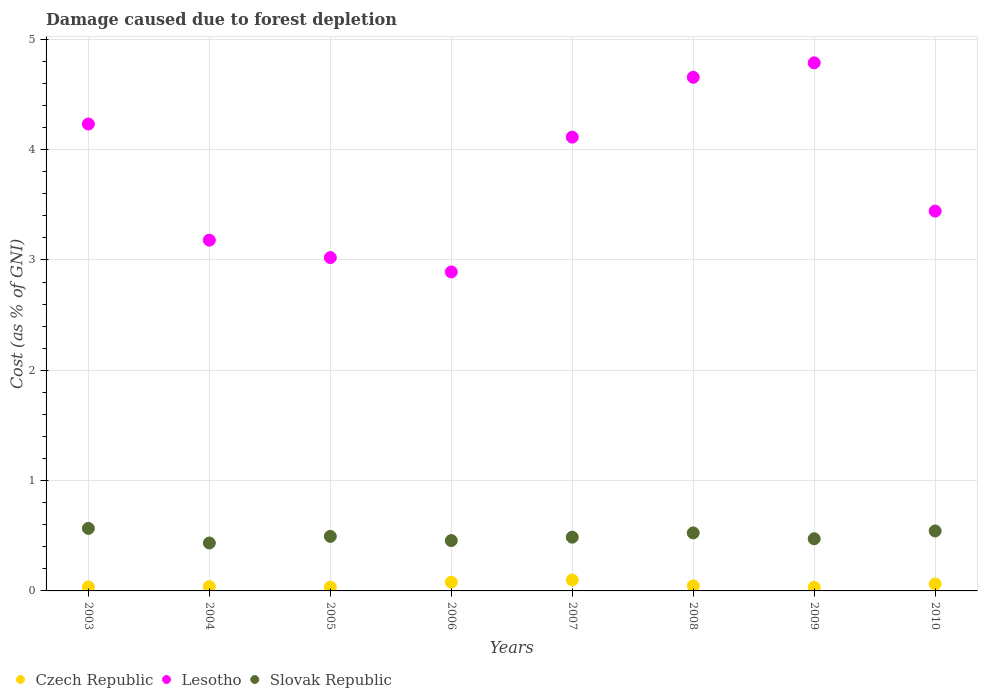What is the cost of damage caused due to forest depletion in Czech Republic in 2004?
Your answer should be compact. 0.04. Across all years, what is the maximum cost of damage caused due to forest depletion in Lesotho?
Offer a terse response. 4.79. Across all years, what is the minimum cost of damage caused due to forest depletion in Lesotho?
Your answer should be very brief. 2.89. What is the total cost of damage caused due to forest depletion in Czech Republic in the graph?
Ensure brevity in your answer.  0.43. What is the difference between the cost of damage caused due to forest depletion in Slovak Republic in 2003 and that in 2007?
Provide a succinct answer. 0.08. What is the difference between the cost of damage caused due to forest depletion in Lesotho in 2003 and the cost of damage caused due to forest depletion in Czech Republic in 2009?
Offer a very short reply. 4.2. What is the average cost of damage caused due to forest depletion in Slovak Republic per year?
Offer a terse response. 0.5. In the year 2009, what is the difference between the cost of damage caused due to forest depletion in Czech Republic and cost of damage caused due to forest depletion in Slovak Republic?
Keep it short and to the point. -0.44. In how many years, is the cost of damage caused due to forest depletion in Czech Republic greater than 0.8 %?
Offer a terse response. 0. What is the ratio of the cost of damage caused due to forest depletion in Czech Republic in 2007 to that in 2009?
Your response must be concise. 3.05. Is the cost of damage caused due to forest depletion in Lesotho in 2006 less than that in 2009?
Offer a very short reply. Yes. What is the difference between the highest and the second highest cost of damage caused due to forest depletion in Slovak Republic?
Your answer should be compact. 0.02. What is the difference between the highest and the lowest cost of damage caused due to forest depletion in Czech Republic?
Provide a succinct answer. 0.07. Is the sum of the cost of damage caused due to forest depletion in Slovak Republic in 2007 and 2010 greater than the maximum cost of damage caused due to forest depletion in Czech Republic across all years?
Your answer should be compact. Yes. Is it the case that in every year, the sum of the cost of damage caused due to forest depletion in Lesotho and cost of damage caused due to forest depletion in Czech Republic  is greater than the cost of damage caused due to forest depletion in Slovak Republic?
Your answer should be very brief. Yes. Does the cost of damage caused due to forest depletion in Czech Republic monotonically increase over the years?
Your answer should be compact. No. Is the cost of damage caused due to forest depletion in Czech Republic strictly less than the cost of damage caused due to forest depletion in Lesotho over the years?
Offer a terse response. Yes. How many years are there in the graph?
Your answer should be very brief. 8. Are the values on the major ticks of Y-axis written in scientific E-notation?
Give a very brief answer. No. Does the graph contain any zero values?
Ensure brevity in your answer.  No. Does the graph contain grids?
Keep it short and to the point. Yes. How are the legend labels stacked?
Offer a terse response. Horizontal. What is the title of the graph?
Your response must be concise. Damage caused due to forest depletion. Does "Canada" appear as one of the legend labels in the graph?
Provide a succinct answer. No. What is the label or title of the Y-axis?
Make the answer very short. Cost (as % of GNI). What is the Cost (as % of GNI) of Czech Republic in 2003?
Provide a short and direct response. 0.04. What is the Cost (as % of GNI) of Lesotho in 2003?
Offer a terse response. 4.23. What is the Cost (as % of GNI) in Slovak Republic in 2003?
Ensure brevity in your answer.  0.57. What is the Cost (as % of GNI) of Czech Republic in 2004?
Give a very brief answer. 0.04. What is the Cost (as % of GNI) of Lesotho in 2004?
Give a very brief answer. 3.18. What is the Cost (as % of GNI) in Slovak Republic in 2004?
Provide a short and direct response. 0.43. What is the Cost (as % of GNI) of Czech Republic in 2005?
Your response must be concise. 0.03. What is the Cost (as % of GNI) in Lesotho in 2005?
Make the answer very short. 3.02. What is the Cost (as % of GNI) in Slovak Republic in 2005?
Make the answer very short. 0.49. What is the Cost (as % of GNI) in Czech Republic in 2006?
Ensure brevity in your answer.  0.08. What is the Cost (as % of GNI) in Lesotho in 2006?
Provide a succinct answer. 2.89. What is the Cost (as % of GNI) in Slovak Republic in 2006?
Offer a very short reply. 0.46. What is the Cost (as % of GNI) in Czech Republic in 2007?
Make the answer very short. 0.1. What is the Cost (as % of GNI) in Lesotho in 2007?
Keep it short and to the point. 4.11. What is the Cost (as % of GNI) in Slovak Republic in 2007?
Provide a short and direct response. 0.49. What is the Cost (as % of GNI) in Czech Republic in 2008?
Provide a succinct answer. 0.05. What is the Cost (as % of GNI) in Lesotho in 2008?
Give a very brief answer. 4.66. What is the Cost (as % of GNI) of Slovak Republic in 2008?
Provide a succinct answer. 0.53. What is the Cost (as % of GNI) in Czech Republic in 2009?
Your answer should be compact. 0.03. What is the Cost (as % of GNI) in Lesotho in 2009?
Provide a succinct answer. 4.79. What is the Cost (as % of GNI) in Slovak Republic in 2009?
Offer a very short reply. 0.47. What is the Cost (as % of GNI) in Czech Republic in 2010?
Provide a succinct answer. 0.06. What is the Cost (as % of GNI) of Lesotho in 2010?
Provide a succinct answer. 3.44. What is the Cost (as % of GNI) in Slovak Republic in 2010?
Offer a very short reply. 0.54. Across all years, what is the maximum Cost (as % of GNI) of Czech Republic?
Provide a short and direct response. 0.1. Across all years, what is the maximum Cost (as % of GNI) in Lesotho?
Give a very brief answer. 4.79. Across all years, what is the maximum Cost (as % of GNI) in Slovak Republic?
Provide a short and direct response. 0.57. Across all years, what is the minimum Cost (as % of GNI) in Czech Republic?
Keep it short and to the point. 0.03. Across all years, what is the minimum Cost (as % of GNI) in Lesotho?
Your answer should be very brief. 2.89. Across all years, what is the minimum Cost (as % of GNI) in Slovak Republic?
Your response must be concise. 0.43. What is the total Cost (as % of GNI) of Czech Republic in the graph?
Keep it short and to the point. 0.43. What is the total Cost (as % of GNI) of Lesotho in the graph?
Your answer should be very brief. 30.33. What is the total Cost (as % of GNI) in Slovak Republic in the graph?
Ensure brevity in your answer.  3.98. What is the difference between the Cost (as % of GNI) in Czech Republic in 2003 and that in 2004?
Your response must be concise. -0. What is the difference between the Cost (as % of GNI) of Lesotho in 2003 and that in 2004?
Your answer should be very brief. 1.05. What is the difference between the Cost (as % of GNI) in Slovak Republic in 2003 and that in 2004?
Keep it short and to the point. 0.13. What is the difference between the Cost (as % of GNI) in Czech Republic in 2003 and that in 2005?
Ensure brevity in your answer.  0. What is the difference between the Cost (as % of GNI) of Lesotho in 2003 and that in 2005?
Offer a very short reply. 1.21. What is the difference between the Cost (as % of GNI) in Slovak Republic in 2003 and that in 2005?
Offer a very short reply. 0.07. What is the difference between the Cost (as % of GNI) in Czech Republic in 2003 and that in 2006?
Give a very brief answer. -0.04. What is the difference between the Cost (as % of GNI) of Lesotho in 2003 and that in 2006?
Give a very brief answer. 1.34. What is the difference between the Cost (as % of GNI) in Slovak Republic in 2003 and that in 2006?
Make the answer very short. 0.11. What is the difference between the Cost (as % of GNI) of Czech Republic in 2003 and that in 2007?
Provide a short and direct response. -0.06. What is the difference between the Cost (as % of GNI) of Lesotho in 2003 and that in 2007?
Your answer should be compact. 0.12. What is the difference between the Cost (as % of GNI) of Slovak Republic in 2003 and that in 2007?
Your answer should be compact. 0.08. What is the difference between the Cost (as % of GNI) in Czech Republic in 2003 and that in 2008?
Ensure brevity in your answer.  -0.01. What is the difference between the Cost (as % of GNI) of Lesotho in 2003 and that in 2008?
Provide a short and direct response. -0.42. What is the difference between the Cost (as % of GNI) of Slovak Republic in 2003 and that in 2008?
Give a very brief answer. 0.04. What is the difference between the Cost (as % of GNI) in Czech Republic in 2003 and that in 2009?
Your answer should be very brief. 0. What is the difference between the Cost (as % of GNI) of Lesotho in 2003 and that in 2009?
Provide a succinct answer. -0.56. What is the difference between the Cost (as % of GNI) of Slovak Republic in 2003 and that in 2009?
Provide a short and direct response. 0.09. What is the difference between the Cost (as % of GNI) in Czech Republic in 2003 and that in 2010?
Offer a very short reply. -0.03. What is the difference between the Cost (as % of GNI) in Lesotho in 2003 and that in 2010?
Keep it short and to the point. 0.79. What is the difference between the Cost (as % of GNI) in Slovak Republic in 2003 and that in 2010?
Your response must be concise. 0.02. What is the difference between the Cost (as % of GNI) in Czech Republic in 2004 and that in 2005?
Provide a short and direct response. 0. What is the difference between the Cost (as % of GNI) of Lesotho in 2004 and that in 2005?
Give a very brief answer. 0.16. What is the difference between the Cost (as % of GNI) in Slovak Republic in 2004 and that in 2005?
Offer a terse response. -0.06. What is the difference between the Cost (as % of GNI) in Czech Republic in 2004 and that in 2006?
Ensure brevity in your answer.  -0.04. What is the difference between the Cost (as % of GNI) in Lesotho in 2004 and that in 2006?
Your answer should be very brief. 0.29. What is the difference between the Cost (as % of GNI) in Slovak Republic in 2004 and that in 2006?
Provide a succinct answer. -0.02. What is the difference between the Cost (as % of GNI) in Czech Republic in 2004 and that in 2007?
Provide a short and direct response. -0.06. What is the difference between the Cost (as % of GNI) of Lesotho in 2004 and that in 2007?
Give a very brief answer. -0.93. What is the difference between the Cost (as % of GNI) of Slovak Republic in 2004 and that in 2007?
Offer a terse response. -0.05. What is the difference between the Cost (as % of GNI) in Czech Republic in 2004 and that in 2008?
Keep it short and to the point. -0.01. What is the difference between the Cost (as % of GNI) of Lesotho in 2004 and that in 2008?
Ensure brevity in your answer.  -1.48. What is the difference between the Cost (as % of GNI) of Slovak Republic in 2004 and that in 2008?
Offer a terse response. -0.09. What is the difference between the Cost (as % of GNI) of Czech Republic in 2004 and that in 2009?
Offer a terse response. 0.01. What is the difference between the Cost (as % of GNI) in Lesotho in 2004 and that in 2009?
Offer a terse response. -1.61. What is the difference between the Cost (as % of GNI) of Slovak Republic in 2004 and that in 2009?
Ensure brevity in your answer.  -0.04. What is the difference between the Cost (as % of GNI) of Czech Republic in 2004 and that in 2010?
Ensure brevity in your answer.  -0.02. What is the difference between the Cost (as % of GNI) in Lesotho in 2004 and that in 2010?
Provide a succinct answer. -0.26. What is the difference between the Cost (as % of GNI) of Slovak Republic in 2004 and that in 2010?
Make the answer very short. -0.11. What is the difference between the Cost (as % of GNI) of Czech Republic in 2005 and that in 2006?
Give a very brief answer. -0.04. What is the difference between the Cost (as % of GNI) of Lesotho in 2005 and that in 2006?
Give a very brief answer. 0.13. What is the difference between the Cost (as % of GNI) in Slovak Republic in 2005 and that in 2006?
Provide a succinct answer. 0.04. What is the difference between the Cost (as % of GNI) in Czech Republic in 2005 and that in 2007?
Make the answer very short. -0.06. What is the difference between the Cost (as % of GNI) of Lesotho in 2005 and that in 2007?
Ensure brevity in your answer.  -1.09. What is the difference between the Cost (as % of GNI) of Slovak Republic in 2005 and that in 2007?
Keep it short and to the point. 0.01. What is the difference between the Cost (as % of GNI) in Czech Republic in 2005 and that in 2008?
Offer a very short reply. -0.01. What is the difference between the Cost (as % of GNI) of Lesotho in 2005 and that in 2008?
Give a very brief answer. -1.63. What is the difference between the Cost (as % of GNI) of Slovak Republic in 2005 and that in 2008?
Offer a terse response. -0.03. What is the difference between the Cost (as % of GNI) of Czech Republic in 2005 and that in 2009?
Keep it short and to the point. 0. What is the difference between the Cost (as % of GNI) in Lesotho in 2005 and that in 2009?
Ensure brevity in your answer.  -1.77. What is the difference between the Cost (as % of GNI) of Slovak Republic in 2005 and that in 2009?
Your answer should be very brief. 0.02. What is the difference between the Cost (as % of GNI) in Czech Republic in 2005 and that in 2010?
Offer a very short reply. -0.03. What is the difference between the Cost (as % of GNI) of Lesotho in 2005 and that in 2010?
Ensure brevity in your answer.  -0.42. What is the difference between the Cost (as % of GNI) of Slovak Republic in 2005 and that in 2010?
Ensure brevity in your answer.  -0.05. What is the difference between the Cost (as % of GNI) of Czech Republic in 2006 and that in 2007?
Offer a very short reply. -0.02. What is the difference between the Cost (as % of GNI) of Lesotho in 2006 and that in 2007?
Your response must be concise. -1.22. What is the difference between the Cost (as % of GNI) of Slovak Republic in 2006 and that in 2007?
Your response must be concise. -0.03. What is the difference between the Cost (as % of GNI) of Czech Republic in 2006 and that in 2008?
Your response must be concise. 0.03. What is the difference between the Cost (as % of GNI) of Lesotho in 2006 and that in 2008?
Provide a short and direct response. -1.76. What is the difference between the Cost (as % of GNI) of Slovak Republic in 2006 and that in 2008?
Offer a very short reply. -0.07. What is the difference between the Cost (as % of GNI) of Czech Republic in 2006 and that in 2009?
Your response must be concise. 0.05. What is the difference between the Cost (as % of GNI) in Lesotho in 2006 and that in 2009?
Provide a succinct answer. -1.9. What is the difference between the Cost (as % of GNI) of Slovak Republic in 2006 and that in 2009?
Provide a short and direct response. -0.02. What is the difference between the Cost (as % of GNI) of Czech Republic in 2006 and that in 2010?
Offer a very short reply. 0.02. What is the difference between the Cost (as % of GNI) of Lesotho in 2006 and that in 2010?
Provide a short and direct response. -0.55. What is the difference between the Cost (as % of GNI) of Slovak Republic in 2006 and that in 2010?
Provide a short and direct response. -0.09. What is the difference between the Cost (as % of GNI) in Czech Republic in 2007 and that in 2008?
Make the answer very short. 0.05. What is the difference between the Cost (as % of GNI) in Lesotho in 2007 and that in 2008?
Your answer should be very brief. -0.54. What is the difference between the Cost (as % of GNI) of Slovak Republic in 2007 and that in 2008?
Provide a short and direct response. -0.04. What is the difference between the Cost (as % of GNI) of Czech Republic in 2007 and that in 2009?
Offer a very short reply. 0.07. What is the difference between the Cost (as % of GNI) of Lesotho in 2007 and that in 2009?
Offer a very short reply. -0.67. What is the difference between the Cost (as % of GNI) in Slovak Republic in 2007 and that in 2009?
Keep it short and to the point. 0.01. What is the difference between the Cost (as % of GNI) in Czech Republic in 2007 and that in 2010?
Ensure brevity in your answer.  0.04. What is the difference between the Cost (as % of GNI) in Lesotho in 2007 and that in 2010?
Your answer should be very brief. 0.67. What is the difference between the Cost (as % of GNI) in Slovak Republic in 2007 and that in 2010?
Your answer should be compact. -0.06. What is the difference between the Cost (as % of GNI) in Czech Republic in 2008 and that in 2009?
Provide a succinct answer. 0.01. What is the difference between the Cost (as % of GNI) of Lesotho in 2008 and that in 2009?
Offer a very short reply. -0.13. What is the difference between the Cost (as % of GNI) in Slovak Republic in 2008 and that in 2009?
Your response must be concise. 0.05. What is the difference between the Cost (as % of GNI) of Czech Republic in 2008 and that in 2010?
Provide a short and direct response. -0.02. What is the difference between the Cost (as % of GNI) in Lesotho in 2008 and that in 2010?
Offer a terse response. 1.21. What is the difference between the Cost (as % of GNI) of Slovak Republic in 2008 and that in 2010?
Your answer should be very brief. -0.02. What is the difference between the Cost (as % of GNI) of Czech Republic in 2009 and that in 2010?
Keep it short and to the point. -0.03. What is the difference between the Cost (as % of GNI) of Lesotho in 2009 and that in 2010?
Ensure brevity in your answer.  1.34. What is the difference between the Cost (as % of GNI) in Slovak Republic in 2009 and that in 2010?
Keep it short and to the point. -0.07. What is the difference between the Cost (as % of GNI) of Czech Republic in 2003 and the Cost (as % of GNI) of Lesotho in 2004?
Keep it short and to the point. -3.14. What is the difference between the Cost (as % of GNI) of Czech Republic in 2003 and the Cost (as % of GNI) of Slovak Republic in 2004?
Offer a very short reply. -0.4. What is the difference between the Cost (as % of GNI) in Lesotho in 2003 and the Cost (as % of GNI) in Slovak Republic in 2004?
Make the answer very short. 3.8. What is the difference between the Cost (as % of GNI) in Czech Republic in 2003 and the Cost (as % of GNI) in Lesotho in 2005?
Keep it short and to the point. -2.99. What is the difference between the Cost (as % of GNI) in Czech Republic in 2003 and the Cost (as % of GNI) in Slovak Republic in 2005?
Keep it short and to the point. -0.46. What is the difference between the Cost (as % of GNI) in Lesotho in 2003 and the Cost (as % of GNI) in Slovak Republic in 2005?
Your answer should be compact. 3.74. What is the difference between the Cost (as % of GNI) in Czech Republic in 2003 and the Cost (as % of GNI) in Lesotho in 2006?
Give a very brief answer. -2.86. What is the difference between the Cost (as % of GNI) of Czech Republic in 2003 and the Cost (as % of GNI) of Slovak Republic in 2006?
Provide a short and direct response. -0.42. What is the difference between the Cost (as % of GNI) of Lesotho in 2003 and the Cost (as % of GNI) of Slovak Republic in 2006?
Ensure brevity in your answer.  3.78. What is the difference between the Cost (as % of GNI) of Czech Republic in 2003 and the Cost (as % of GNI) of Lesotho in 2007?
Your answer should be compact. -4.08. What is the difference between the Cost (as % of GNI) in Czech Republic in 2003 and the Cost (as % of GNI) in Slovak Republic in 2007?
Keep it short and to the point. -0.45. What is the difference between the Cost (as % of GNI) of Lesotho in 2003 and the Cost (as % of GNI) of Slovak Republic in 2007?
Provide a short and direct response. 3.75. What is the difference between the Cost (as % of GNI) of Czech Republic in 2003 and the Cost (as % of GNI) of Lesotho in 2008?
Keep it short and to the point. -4.62. What is the difference between the Cost (as % of GNI) of Czech Republic in 2003 and the Cost (as % of GNI) of Slovak Republic in 2008?
Offer a very short reply. -0.49. What is the difference between the Cost (as % of GNI) of Lesotho in 2003 and the Cost (as % of GNI) of Slovak Republic in 2008?
Your answer should be very brief. 3.71. What is the difference between the Cost (as % of GNI) of Czech Republic in 2003 and the Cost (as % of GNI) of Lesotho in 2009?
Your answer should be compact. -4.75. What is the difference between the Cost (as % of GNI) of Czech Republic in 2003 and the Cost (as % of GNI) of Slovak Republic in 2009?
Ensure brevity in your answer.  -0.44. What is the difference between the Cost (as % of GNI) in Lesotho in 2003 and the Cost (as % of GNI) in Slovak Republic in 2009?
Ensure brevity in your answer.  3.76. What is the difference between the Cost (as % of GNI) of Czech Republic in 2003 and the Cost (as % of GNI) of Lesotho in 2010?
Your response must be concise. -3.41. What is the difference between the Cost (as % of GNI) in Czech Republic in 2003 and the Cost (as % of GNI) in Slovak Republic in 2010?
Make the answer very short. -0.51. What is the difference between the Cost (as % of GNI) of Lesotho in 2003 and the Cost (as % of GNI) of Slovak Republic in 2010?
Your response must be concise. 3.69. What is the difference between the Cost (as % of GNI) of Czech Republic in 2004 and the Cost (as % of GNI) of Lesotho in 2005?
Your answer should be compact. -2.98. What is the difference between the Cost (as % of GNI) of Czech Republic in 2004 and the Cost (as % of GNI) of Slovak Republic in 2005?
Provide a short and direct response. -0.46. What is the difference between the Cost (as % of GNI) of Lesotho in 2004 and the Cost (as % of GNI) of Slovak Republic in 2005?
Your answer should be compact. 2.69. What is the difference between the Cost (as % of GNI) in Czech Republic in 2004 and the Cost (as % of GNI) in Lesotho in 2006?
Give a very brief answer. -2.85. What is the difference between the Cost (as % of GNI) of Czech Republic in 2004 and the Cost (as % of GNI) of Slovak Republic in 2006?
Make the answer very short. -0.42. What is the difference between the Cost (as % of GNI) in Lesotho in 2004 and the Cost (as % of GNI) in Slovak Republic in 2006?
Offer a terse response. 2.72. What is the difference between the Cost (as % of GNI) in Czech Republic in 2004 and the Cost (as % of GNI) in Lesotho in 2007?
Your answer should be very brief. -4.07. What is the difference between the Cost (as % of GNI) in Czech Republic in 2004 and the Cost (as % of GNI) in Slovak Republic in 2007?
Your answer should be very brief. -0.45. What is the difference between the Cost (as % of GNI) of Lesotho in 2004 and the Cost (as % of GNI) of Slovak Republic in 2007?
Your answer should be very brief. 2.69. What is the difference between the Cost (as % of GNI) of Czech Republic in 2004 and the Cost (as % of GNI) of Lesotho in 2008?
Offer a very short reply. -4.62. What is the difference between the Cost (as % of GNI) in Czech Republic in 2004 and the Cost (as % of GNI) in Slovak Republic in 2008?
Ensure brevity in your answer.  -0.49. What is the difference between the Cost (as % of GNI) in Lesotho in 2004 and the Cost (as % of GNI) in Slovak Republic in 2008?
Provide a short and direct response. 2.65. What is the difference between the Cost (as % of GNI) in Czech Republic in 2004 and the Cost (as % of GNI) in Lesotho in 2009?
Make the answer very short. -4.75. What is the difference between the Cost (as % of GNI) of Czech Republic in 2004 and the Cost (as % of GNI) of Slovak Republic in 2009?
Offer a terse response. -0.43. What is the difference between the Cost (as % of GNI) in Lesotho in 2004 and the Cost (as % of GNI) in Slovak Republic in 2009?
Give a very brief answer. 2.71. What is the difference between the Cost (as % of GNI) of Czech Republic in 2004 and the Cost (as % of GNI) of Lesotho in 2010?
Provide a succinct answer. -3.4. What is the difference between the Cost (as % of GNI) of Czech Republic in 2004 and the Cost (as % of GNI) of Slovak Republic in 2010?
Your answer should be very brief. -0.5. What is the difference between the Cost (as % of GNI) in Lesotho in 2004 and the Cost (as % of GNI) in Slovak Republic in 2010?
Offer a terse response. 2.64. What is the difference between the Cost (as % of GNI) in Czech Republic in 2005 and the Cost (as % of GNI) in Lesotho in 2006?
Ensure brevity in your answer.  -2.86. What is the difference between the Cost (as % of GNI) in Czech Republic in 2005 and the Cost (as % of GNI) in Slovak Republic in 2006?
Provide a short and direct response. -0.42. What is the difference between the Cost (as % of GNI) in Lesotho in 2005 and the Cost (as % of GNI) in Slovak Republic in 2006?
Provide a short and direct response. 2.57. What is the difference between the Cost (as % of GNI) of Czech Republic in 2005 and the Cost (as % of GNI) of Lesotho in 2007?
Keep it short and to the point. -4.08. What is the difference between the Cost (as % of GNI) of Czech Republic in 2005 and the Cost (as % of GNI) of Slovak Republic in 2007?
Ensure brevity in your answer.  -0.45. What is the difference between the Cost (as % of GNI) in Lesotho in 2005 and the Cost (as % of GNI) in Slovak Republic in 2007?
Keep it short and to the point. 2.53. What is the difference between the Cost (as % of GNI) of Czech Republic in 2005 and the Cost (as % of GNI) of Lesotho in 2008?
Offer a very short reply. -4.62. What is the difference between the Cost (as % of GNI) in Czech Republic in 2005 and the Cost (as % of GNI) in Slovak Republic in 2008?
Your answer should be very brief. -0.49. What is the difference between the Cost (as % of GNI) in Lesotho in 2005 and the Cost (as % of GNI) in Slovak Republic in 2008?
Your answer should be very brief. 2.5. What is the difference between the Cost (as % of GNI) of Czech Republic in 2005 and the Cost (as % of GNI) of Lesotho in 2009?
Give a very brief answer. -4.75. What is the difference between the Cost (as % of GNI) in Czech Republic in 2005 and the Cost (as % of GNI) in Slovak Republic in 2009?
Make the answer very short. -0.44. What is the difference between the Cost (as % of GNI) in Lesotho in 2005 and the Cost (as % of GNI) in Slovak Republic in 2009?
Provide a succinct answer. 2.55. What is the difference between the Cost (as % of GNI) of Czech Republic in 2005 and the Cost (as % of GNI) of Lesotho in 2010?
Your answer should be compact. -3.41. What is the difference between the Cost (as % of GNI) in Czech Republic in 2005 and the Cost (as % of GNI) in Slovak Republic in 2010?
Your answer should be very brief. -0.51. What is the difference between the Cost (as % of GNI) in Lesotho in 2005 and the Cost (as % of GNI) in Slovak Republic in 2010?
Ensure brevity in your answer.  2.48. What is the difference between the Cost (as % of GNI) in Czech Republic in 2006 and the Cost (as % of GNI) in Lesotho in 2007?
Provide a short and direct response. -4.03. What is the difference between the Cost (as % of GNI) of Czech Republic in 2006 and the Cost (as % of GNI) of Slovak Republic in 2007?
Offer a terse response. -0.41. What is the difference between the Cost (as % of GNI) of Lesotho in 2006 and the Cost (as % of GNI) of Slovak Republic in 2007?
Your answer should be compact. 2.4. What is the difference between the Cost (as % of GNI) of Czech Republic in 2006 and the Cost (as % of GNI) of Lesotho in 2008?
Make the answer very short. -4.58. What is the difference between the Cost (as % of GNI) of Czech Republic in 2006 and the Cost (as % of GNI) of Slovak Republic in 2008?
Make the answer very short. -0.45. What is the difference between the Cost (as % of GNI) of Lesotho in 2006 and the Cost (as % of GNI) of Slovak Republic in 2008?
Give a very brief answer. 2.37. What is the difference between the Cost (as % of GNI) in Czech Republic in 2006 and the Cost (as % of GNI) in Lesotho in 2009?
Keep it short and to the point. -4.71. What is the difference between the Cost (as % of GNI) in Czech Republic in 2006 and the Cost (as % of GNI) in Slovak Republic in 2009?
Provide a short and direct response. -0.39. What is the difference between the Cost (as % of GNI) in Lesotho in 2006 and the Cost (as % of GNI) in Slovak Republic in 2009?
Your answer should be very brief. 2.42. What is the difference between the Cost (as % of GNI) in Czech Republic in 2006 and the Cost (as % of GNI) in Lesotho in 2010?
Ensure brevity in your answer.  -3.36. What is the difference between the Cost (as % of GNI) in Czech Republic in 2006 and the Cost (as % of GNI) in Slovak Republic in 2010?
Provide a short and direct response. -0.46. What is the difference between the Cost (as % of GNI) in Lesotho in 2006 and the Cost (as % of GNI) in Slovak Republic in 2010?
Your answer should be compact. 2.35. What is the difference between the Cost (as % of GNI) in Czech Republic in 2007 and the Cost (as % of GNI) in Lesotho in 2008?
Ensure brevity in your answer.  -4.56. What is the difference between the Cost (as % of GNI) in Czech Republic in 2007 and the Cost (as % of GNI) in Slovak Republic in 2008?
Provide a succinct answer. -0.43. What is the difference between the Cost (as % of GNI) of Lesotho in 2007 and the Cost (as % of GNI) of Slovak Republic in 2008?
Offer a terse response. 3.59. What is the difference between the Cost (as % of GNI) in Czech Republic in 2007 and the Cost (as % of GNI) in Lesotho in 2009?
Give a very brief answer. -4.69. What is the difference between the Cost (as % of GNI) in Czech Republic in 2007 and the Cost (as % of GNI) in Slovak Republic in 2009?
Ensure brevity in your answer.  -0.37. What is the difference between the Cost (as % of GNI) in Lesotho in 2007 and the Cost (as % of GNI) in Slovak Republic in 2009?
Make the answer very short. 3.64. What is the difference between the Cost (as % of GNI) of Czech Republic in 2007 and the Cost (as % of GNI) of Lesotho in 2010?
Offer a terse response. -3.34. What is the difference between the Cost (as % of GNI) in Czech Republic in 2007 and the Cost (as % of GNI) in Slovak Republic in 2010?
Ensure brevity in your answer.  -0.44. What is the difference between the Cost (as % of GNI) of Lesotho in 2007 and the Cost (as % of GNI) of Slovak Republic in 2010?
Ensure brevity in your answer.  3.57. What is the difference between the Cost (as % of GNI) of Czech Republic in 2008 and the Cost (as % of GNI) of Lesotho in 2009?
Provide a short and direct response. -4.74. What is the difference between the Cost (as % of GNI) of Czech Republic in 2008 and the Cost (as % of GNI) of Slovak Republic in 2009?
Offer a very short reply. -0.43. What is the difference between the Cost (as % of GNI) in Lesotho in 2008 and the Cost (as % of GNI) in Slovak Republic in 2009?
Ensure brevity in your answer.  4.18. What is the difference between the Cost (as % of GNI) of Czech Republic in 2008 and the Cost (as % of GNI) of Lesotho in 2010?
Provide a succinct answer. -3.4. What is the difference between the Cost (as % of GNI) in Czech Republic in 2008 and the Cost (as % of GNI) in Slovak Republic in 2010?
Make the answer very short. -0.5. What is the difference between the Cost (as % of GNI) of Lesotho in 2008 and the Cost (as % of GNI) of Slovak Republic in 2010?
Offer a terse response. 4.11. What is the difference between the Cost (as % of GNI) of Czech Republic in 2009 and the Cost (as % of GNI) of Lesotho in 2010?
Offer a terse response. -3.41. What is the difference between the Cost (as % of GNI) in Czech Republic in 2009 and the Cost (as % of GNI) in Slovak Republic in 2010?
Make the answer very short. -0.51. What is the difference between the Cost (as % of GNI) in Lesotho in 2009 and the Cost (as % of GNI) in Slovak Republic in 2010?
Provide a short and direct response. 4.24. What is the average Cost (as % of GNI) in Czech Republic per year?
Keep it short and to the point. 0.05. What is the average Cost (as % of GNI) in Lesotho per year?
Ensure brevity in your answer.  3.79. What is the average Cost (as % of GNI) in Slovak Republic per year?
Ensure brevity in your answer.  0.5. In the year 2003, what is the difference between the Cost (as % of GNI) in Czech Republic and Cost (as % of GNI) in Lesotho?
Provide a succinct answer. -4.2. In the year 2003, what is the difference between the Cost (as % of GNI) in Czech Republic and Cost (as % of GNI) in Slovak Republic?
Offer a terse response. -0.53. In the year 2003, what is the difference between the Cost (as % of GNI) of Lesotho and Cost (as % of GNI) of Slovak Republic?
Your answer should be compact. 3.67. In the year 2004, what is the difference between the Cost (as % of GNI) of Czech Republic and Cost (as % of GNI) of Lesotho?
Provide a succinct answer. -3.14. In the year 2004, what is the difference between the Cost (as % of GNI) of Czech Republic and Cost (as % of GNI) of Slovak Republic?
Your response must be concise. -0.4. In the year 2004, what is the difference between the Cost (as % of GNI) of Lesotho and Cost (as % of GNI) of Slovak Republic?
Provide a short and direct response. 2.75. In the year 2005, what is the difference between the Cost (as % of GNI) of Czech Republic and Cost (as % of GNI) of Lesotho?
Your answer should be compact. -2.99. In the year 2005, what is the difference between the Cost (as % of GNI) in Czech Republic and Cost (as % of GNI) in Slovak Republic?
Make the answer very short. -0.46. In the year 2005, what is the difference between the Cost (as % of GNI) in Lesotho and Cost (as % of GNI) in Slovak Republic?
Your response must be concise. 2.53. In the year 2006, what is the difference between the Cost (as % of GNI) of Czech Republic and Cost (as % of GNI) of Lesotho?
Keep it short and to the point. -2.81. In the year 2006, what is the difference between the Cost (as % of GNI) in Czech Republic and Cost (as % of GNI) in Slovak Republic?
Ensure brevity in your answer.  -0.38. In the year 2006, what is the difference between the Cost (as % of GNI) of Lesotho and Cost (as % of GNI) of Slovak Republic?
Ensure brevity in your answer.  2.44. In the year 2007, what is the difference between the Cost (as % of GNI) in Czech Republic and Cost (as % of GNI) in Lesotho?
Your answer should be very brief. -4.01. In the year 2007, what is the difference between the Cost (as % of GNI) in Czech Republic and Cost (as % of GNI) in Slovak Republic?
Offer a terse response. -0.39. In the year 2007, what is the difference between the Cost (as % of GNI) in Lesotho and Cost (as % of GNI) in Slovak Republic?
Your response must be concise. 3.63. In the year 2008, what is the difference between the Cost (as % of GNI) of Czech Republic and Cost (as % of GNI) of Lesotho?
Offer a terse response. -4.61. In the year 2008, what is the difference between the Cost (as % of GNI) of Czech Republic and Cost (as % of GNI) of Slovak Republic?
Keep it short and to the point. -0.48. In the year 2008, what is the difference between the Cost (as % of GNI) in Lesotho and Cost (as % of GNI) in Slovak Republic?
Keep it short and to the point. 4.13. In the year 2009, what is the difference between the Cost (as % of GNI) in Czech Republic and Cost (as % of GNI) in Lesotho?
Provide a short and direct response. -4.76. In the year 2009, what is the difference between the Cost (as % of GNI) of Czech Republic and Cost (as % of GNI) of Slovak Republic?
Your response must be concise. -0.44. In the year 2009, what is the difference between the Cost (as % of GNI) of Lesotho and Cost (as % of GNI) of Slovak Republic?
Your answer should be compact. 4.31. In the year 2010, what is the difference between the Cost (as % of GNI) in Czech Republic and Cost (as % of GNI) in Lesotho?
Offer a very short reply. -3.38. In the year 2010, what is the difference between the Cost (as % of GNI) in Czech Republic and Cost (as % of GNI) in Slovak Republic?
Ensure brevity in your answer.  -0.48. In the year 2010, what is the difference between the Cost (as % of GNI) in Lesotho and Cost (as % of GNI) in Slovak Republic?
Your response must be concise. 2.9. What is the ratio of the Cost (as % of GNI) of Czech Republic in 2003 to that in 2004?
Offer a very short reply. 0.93. What is the ratio of the Cost (as % of GNI) of Lesotho in 2003 to that in 2004?
Offer a very short reply. 1.33. What is the ratio of the Cost (as % of GNI) of Slovak Republic in 2003 to that in 2004?
Your answer should be compact. 1.3. What is the ratio of the Cost (as % of GNI) of Czech Republic in 2003 to that in 2005?
Ensure brevity in your answer.  1.05. What is the ratio of the Cost (as % of GNI) of Lesotho in 2003 to that in 2005?
Ensure brevity in your answer.  1.4. What is the ratio of the Cost (as % of GNI) in Slovak Republic in 2003 to that in 2005?
Provide a succinct answer. 1.15. What is the ratio of the Cost (as % of GNI) of Czech Republic in 2003 to that in 2006?
Give a very brief answer. 0.46. What is the ratio of the Cost (as % of GNI) of Lesotho in 2003 to that in 2006?
Keep it short and to the point. 1.46. What is the ratio of the Cost (as % of GNI) of Slovak Republic in 2003 to that in 2006?
Make the answer very short. 1.24. What is the ratio of the Cost (as % of GNI) of Czech Republic in 2003 to that in 2007?
Your answer should be compact. 0.37. What is the ratio of the Cost (as % of GNI) of Lesotho in 2003 to that in 2007?
Give a very brief answer. 1.03. What is the ratio of the Cost (as % of GNI) in Slovak Republic in 2003 to that in 2007?
Provide a succinct answer. 1.16. What is the ratio of the Cost (as % of GNI) in Czech Republic in 2003 to that in 2008?
Ensure brevity in your answer.  0.79. What is the ratio of the Cost (as % of GNI) in Lesotho in 2003 to that in 2008?
Your answer should be very brief. 0.91. What is the ratio of the Cost (as % of GNI) in Slovak Republic in 2003 to that in 2008?
Give a very brief answer. 1.08. What is the ratio of the Cost (as % of GNI) of Czech Republic in 2003 to that in 2009?
Your answer should be very brief. 1.12. What is the ratio of the Cost (as % of GNI) of Lesotho in 2003 to that in 2009?
Your response must be concise. 0.88. What is the ratio of the Cost (as % of GNI) in Slovak Republic in 2003 to that in 2009?
Offer a very short reply. 1.2. What is the ratio of the Cost (as % of GNI) in Czech Republic in 2003 to that in 2010?
Your answer should be compact. 0.58. What is the ratio of the Cost (as % of GNI) of Lesotho in 2003 to that in 2010?
Your response must be concise. 1.23. What is the ratio of the Cost (as % of GNI) in Slovak Republic in 2003 to that in 2010?
Your answer should be compact. 1.04. What is the ratio of the Cost (as % of GNI) of Czech Republic in 2004 to that in 2005?
Give a very brief answer. 1.14. What is the ratio of the Cost (as % of GNI) of Lesotho in 2004 to that in 2005?
Provide a short and direct response. 1.05. What is the ratio of the Cost (as % of GNI) in Slovak Republic in 2004 to that in 2005?
Keep it short and to the point. 0.88. What is the ratio of the Cost (as % of GNI) of Czech Republic in 2004 to that in 2006?
Ensure brevity in your answer.  0.49. What is the ratio of the Cost (as % of GNI) of Lesotho in 2004 to that in 2006?
Provide a succinct answer. 1.1. What is the ratio of the Cost (as % of GNI) in Slovak Republic in 2004 to that in 2006?
Provide a short and direct response. 0.95. What is the ratio of the Cost (as % of GNI) of Czech Republic in 2004 to that in 2007?
Ensure brevity in your answer.  0.4. What is the ratio of the Cost (as % of GNI) of Lesotho in 2004 to that in 2007?
Offer a very short reply. 0.77. What is the ratio of the Cost (as % of GNI) of Slovak Republic in 2004 to that in 2007?
Your answer should be compact. 0.89. What is the ratio of the Cost (as % of GNI) of Czech Republic in 2004 to that in 2008?
Your answer should be compact. 0.86. What is the ratio of the Cost (as % of GNI) of Lesotho in 2004 to that in 2008?
Your response must be concise. 0.68. What is the ratio of the Cost (as % of GNI) of Slovak Republic in 2004 to that in 2008?
Offer a very short reply. 0.83. What is the ratio of the Cost (as % of GNI) of Czech Republic in 2004 to that in 2009?
Offer a terse response. 1.21. What is the ratio of the Cost (as % of GNI) of Lesotho in 2004 to that in 2009?
Provide a short and direct response. 0.66. What is the ratio of the Cost (as % of GNI) in Slovak Republic in 2004 to that in 2009?
Provide a short and direct response. 0.92. What is the ratio of the Cost (as % of GNI) of Czech Republic in 2004 to that in 2010?
Give a very brief answer. 0.62. What is the ratio of the Cost (as % of GNI) of Lesotho in 2004 to that in 2010?
Keep it short and to the point. 0.92. What is the ratio of the Cost (as % of GNI) in Slovak Republic in 2004 to that in 2010?
Keep it short and to the point. 0.8. What is the ratio of the Cost (as % of GNI) of Czech Republic in 2005 to that in 2006?
Your answer should be compact. 0.43. What is the ratio of the Cost (as % of GNI) in Lesotho in 2005 to that in 2006?
Your response must be concise. 1.04. What is the ratio of the Cost (as % of GNI) in Slovak Republic in 2005 to that in 2006?
Make the answer very short. 1.08. What is the ratio of the Cost (as % of GNI) of Czech Republic in 2005 to that in 2007?
Your answer should be very brief. 0.35. What is the ratio of the Cost (as % of GNI) of Lesotho in 2005 to that in 2007?
Offer a terse response. 0.73. What is the ratio of the Cost (as % of GNI) in Slovak Republic in 2005 to that in 2007?
Your response must be concise. 1.02. What is the ratio of the Cost (as % of GNI) in Czech Republic in 2005 to that in 2008?
Provide a short and direct response. 0.75. What is the ratio of the Cost (as % of GNI) in Lesotho in 2005 to that in 2008?
Provide a short and direct response. 0.65. What is the ratio of the Cost (as % of GNI) in Slovak Republic in 2005 to that in 2008?
Offer a terse response. 0.94. What is the ratio of the Cost (as % of GNI) in Czech Republic in 2005 to that in 2009?
Offer a very short reply. 1.06. What is the ratio of the Cost (as % of GNI) in Lesotho in 2005 to that in 2009?
Your answer should be compact. 0.63. What is the ratio of the Cost (as % of GNI) of Slovak Republic in 2005 to that in 2009?
Offer a terse response. 1.05. What is the ratio of the Cost (as % of GNI) of Czech Republic in 2005 to that in 2010?
Provide a succinct answer. 0.55. What is the ratio of the Cost (as % of GNI) in Lesotho in 2005 to that in 2010?
Provide a short and direct response. 0.88. What is the ratio of the Cost (as % of GNI) of Slovak Republic in 2005 to that in 2010?
Provide a succinct answer. 0.91. What is the ratio of the Cost (as % of GNI) in Czech Republic in 2006 to that in 2007?
Ensure brevity in your answer.  0.8. What is the ratio of the Cost (as % of GNI) in Lesotho in 2006 to that in 2007?
Make the answer very short. 0.7. What is the ratio of the Cost (as % of GNI) of Slovak Republic in 2006 to that in 2007?
Make the answer very short. 0.94. What is the ratio of the Cost (as % of GNI) in Czech Republic in 2006 to that in 2008?
Ensure brevity in your answer.  1.74. What is the ratio of the Cost (as % of GNI) in Lesotho in 2006 to that in 2008?
Provide a succinct answer. 0.62. What is the ratio of the Cost (as % of GNI) of Slovak Republic in 2006 to that in 2008?
Give a very brief answer. 0.87. What is the ratio of the Cost (as % of GNI) of Czech Republic in 2006 to that in 2009?
Ensure brevity in your answer.  2.45. What is the ratio of the Cost (as % of GNI) in Lesotho in 2006 to that in 2009?
Your answer should be compact. 0.6. What is the ratio of the Cost (as % of GNI) in Slovak Republic in 2006 to that in 2009?
Ensure brevity in your answer.  0.96. What is the ratio of the Cost (as % of GNI) in Czech Republic in 2006 to that in 2010?
Offer a very short reply. 1.26. What is the ratio of the Cost (as % of GNI) in Lesotho in 2006 to that in 2010?
Your answer should be very brief. 0.84. What is the ratio of the Cost (as % of GNI) of Slovak Republic in 2006 to that in 2010?
Provide a short and direct response. 0.84. What is the ratio of the Cost (as % of GNI) of Czech Republic in 2007 to that in 2008?
Ensure brevity in your answer.  2.17. What is the ratio of the Cost (as % of GNI) in Lesotho in 2007 to that in 2008?
Make the answer very short. 0.88. What is the ratio of the Cost (as % of GNI) of Slovak Republic in 2007 to that in 2008?
Your answer should be compact. 0.93. What is the ratio of the Cost (as % of GNI) in Czech Republic in 2007 to that in 2009?
Provide a succinct answer. 3.05. What is the ratio of the Cost (as % of GNI) in Lesotho in 2007 to that in 2009?
Give a very brief answer. 0.86. What is the ratio of the Cost (as % of GNI) in Slovak Republic in 2007 to that in 2009?
Ensure brevity in your answer.  1.03. What is the ratio of the Cost (as % of GNI) of Czech Republic in 2007 to that in 2010?
Offer a very short reply. 1.57. What is the ratio of the Cost (as % of GNI) in Lesotho in 2007 to that in 2010?
Your answer should be compact. 1.19. What is the ratio of the Cost (as % of GNI) in Slovak Republic in 2007 to that in 2010?
Keep it short and to the point. 0.9. What is the ratio of the Cost (as % of GNI) in Czech Republic in 2008 to that in 2009?
Keep it short and to the point. 1.41. What is the ratio of the Cost (as % of GNI) of Lesotho in 2008 to that in 2009?
Provide a short and direct response. 0.97. What is the ratio of the Cost (as % of GNI) in Slovak Republic in 2008 to that in 2009?
Your response must be concise. 1.11. What is the ratio of the Cost (as % of GNI) in Czech Republic in 2008 to that in 2010?
Your answer should be compact. 0.73. What is the ratio of the Cost (as % of GNI) of Lesotho in 2008 to that in 2010?
Provide a succinct answer. 1.35. What is the ratio of the Cost (as % of GNI) in Slovak Republic in 2008 to that in 2010?
Provide a short and direct response. 0.97. What is the ratio of the Cost (as % of GNI) in Czech Republic in 2009 to that in 2010?
Your response must be concise. 0.52. What is the ratio of the Cost (as % of GNI) in Lesotho in 2009 to that in 2010?
Provide a succinct answer. 1.39. What is the ratio of the Cost (as % of GNI) of Slovak Republic in 2009 to that in 2010?
Keep it short and to the point. 0.87. What is the difference between the highest and the second highest Cost (as % of GNI) of Czech Republic?
Provide a short and direct response. 0.02. What is the difference between the highest and the second highest Cost (as % of GNI) of Lesotho?
Provide a short and direct response. 0.13. What is the difference between the highest and the second highest Cost (as % of GNI) of Slovak Republic?
Keep it short and to the point. 0.02. What is the difference between the highest and the lowest Cost (as % of GNI) in Czech Republic?
Make the answer very short. 0.07. What is the difference between the highest and the lowest Cost (as % of GNI) of Lesotho?
Your answer should be very brief. 1.9. What is the difference between the highest and the lowest Cost (as % of GNI) of Slovak Republic?
Your answer should be very brief. 0.13. 